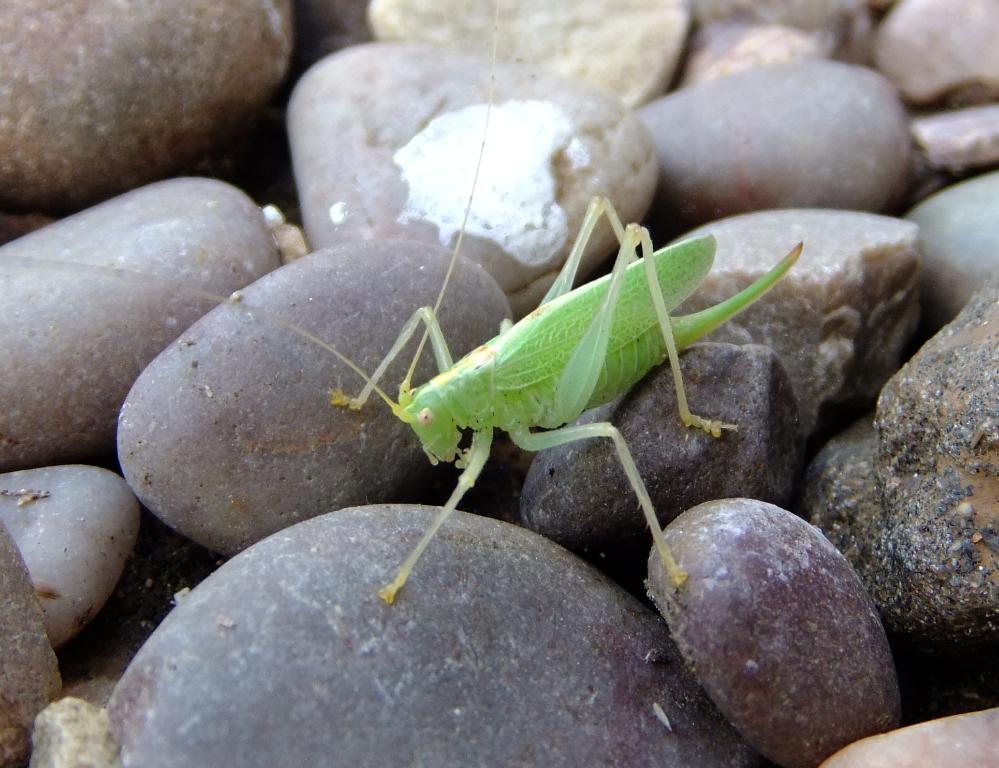Please provide a concise description of this image. In the middle of the picture, we see an insect which looks like a grasshopper. It is in green color. At the bottom, we see the stones. 